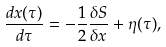Convert formula to latex. <formula><loc_0><loc_0><loc_500><loc_500>\frac { d x ( \tau ) } { d \tau } = - \frac { 1 } { 2 } \frac { \delta S } { \delta x } + \eta ( \tau ) ,</formula> 